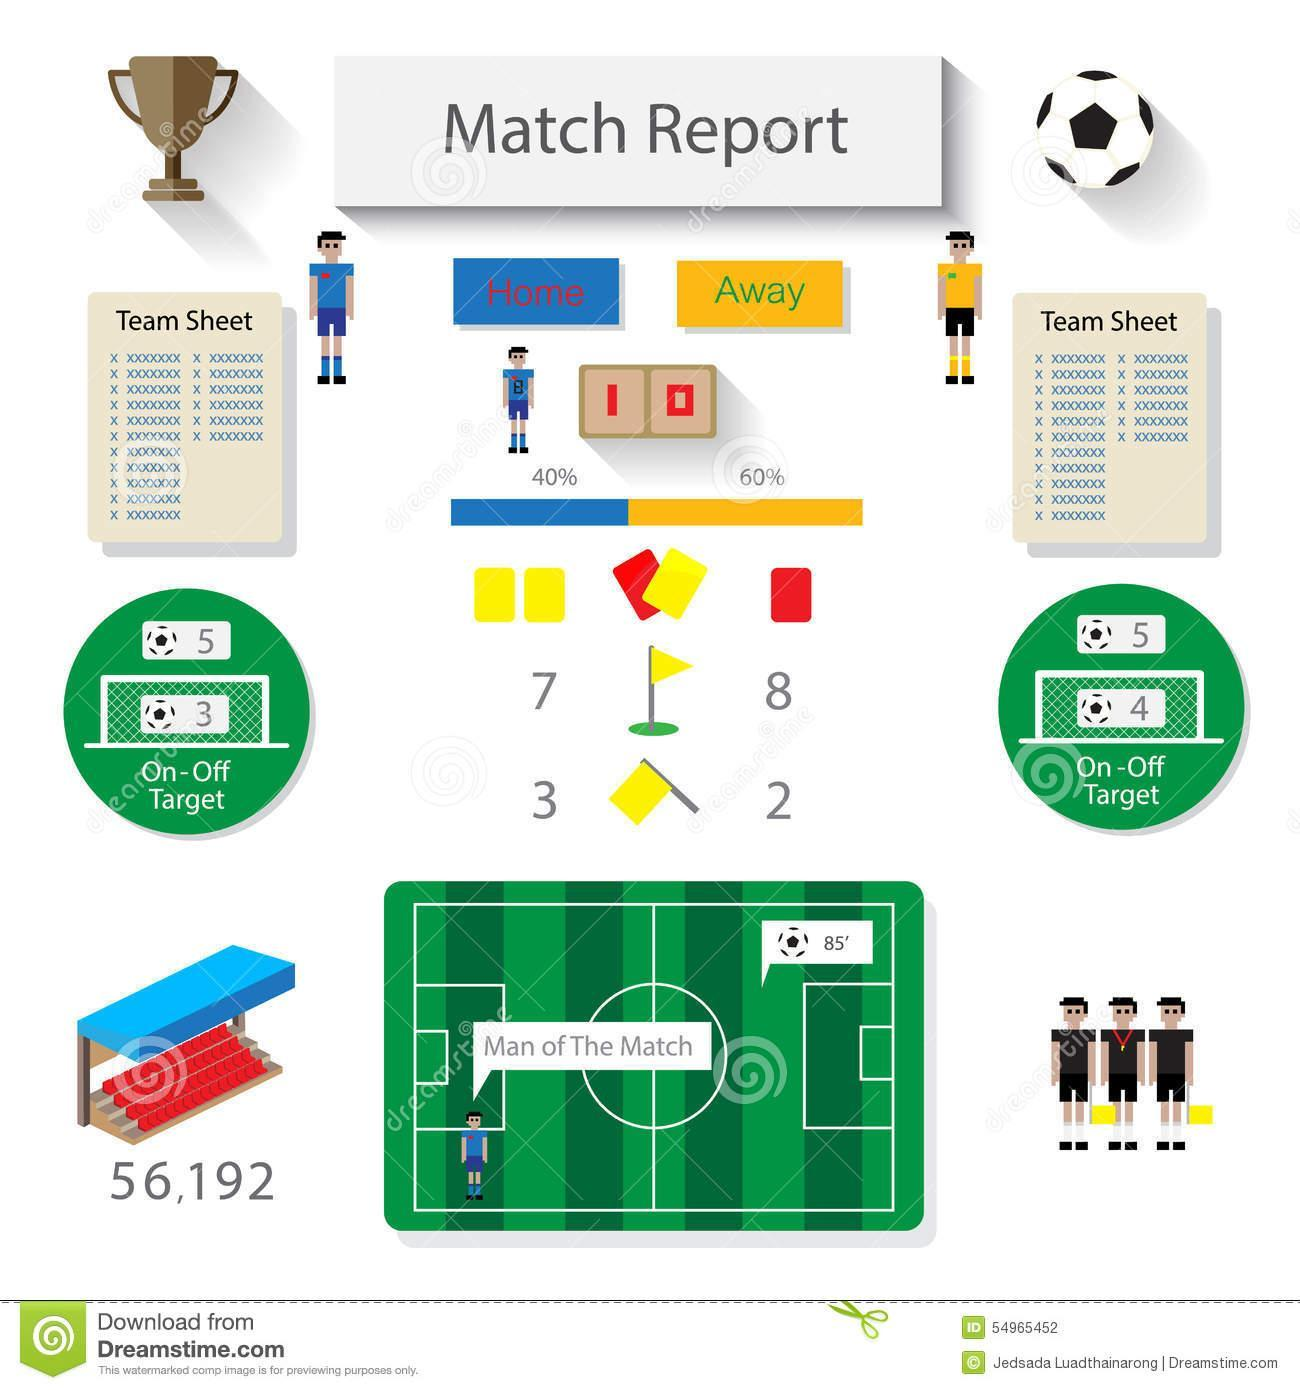What is the game this report is for- cricket, football, volleyball, hockey?
Answer the question with a short phrase. Football How many attempts of the Home team was On target? 3 How many goals were scored by away team? 0 What is the color of Jersey of Home team- red, green, blue, yellow? blue How many attempts of the Away team was On target? 4 What is the color of Jersey of Away team- red, green, blue, yellow? yellow What is the ball possession of the Away team? 60% Who won the match? Home 